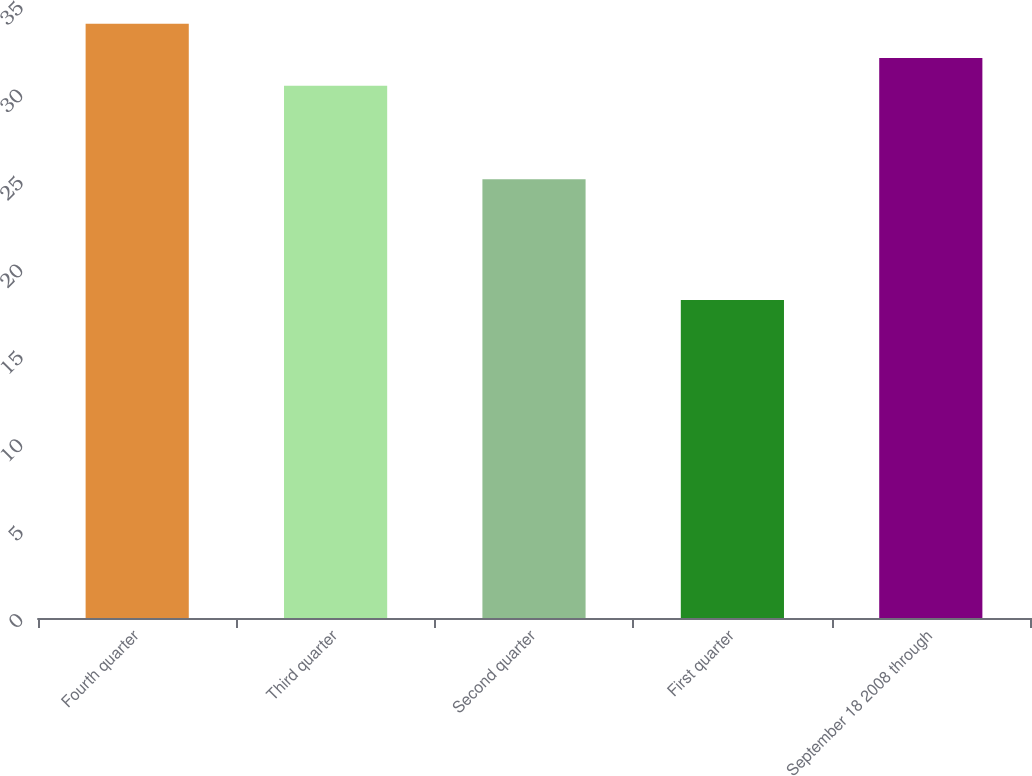Convert chart. <chart><loc_0><loc_0><loc_500><loc_500><bar_chart><fcel>Fourth quarter<fcel>Third quarter<fcel>Second quarter<fcel>First quarter<fcel>September 18 2008 through<nl><fcel>33.99<fcel>30.44<fcel>25.09<fcel>18.19<fcel>32.02<nl></chart> 